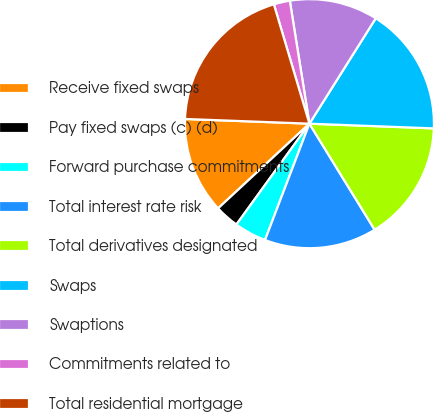Convert chart to OTSL. <chart><loc_0><loc_0><loc_500><loc_500><pie_chart><fcel>Receive fixed swaps<fcel>Pay fixed swaps (c) (d)<fcel>Forward purchase commitments<fcel>Total interest rate risk<fcel>Total derivatives designated<fcel>Swaps<fcel>Swaptions<fcel>Commitments related to<fcel>Total residential mortgage<nl><fcel>12.5%<fcel>3.13%<fcel>4.17%<fcel>14.58%<fcel>15.62%<fcel>16.66%<fcel>11.46%<fcel>2.09%<fcel>19.79%<nl></chart> 